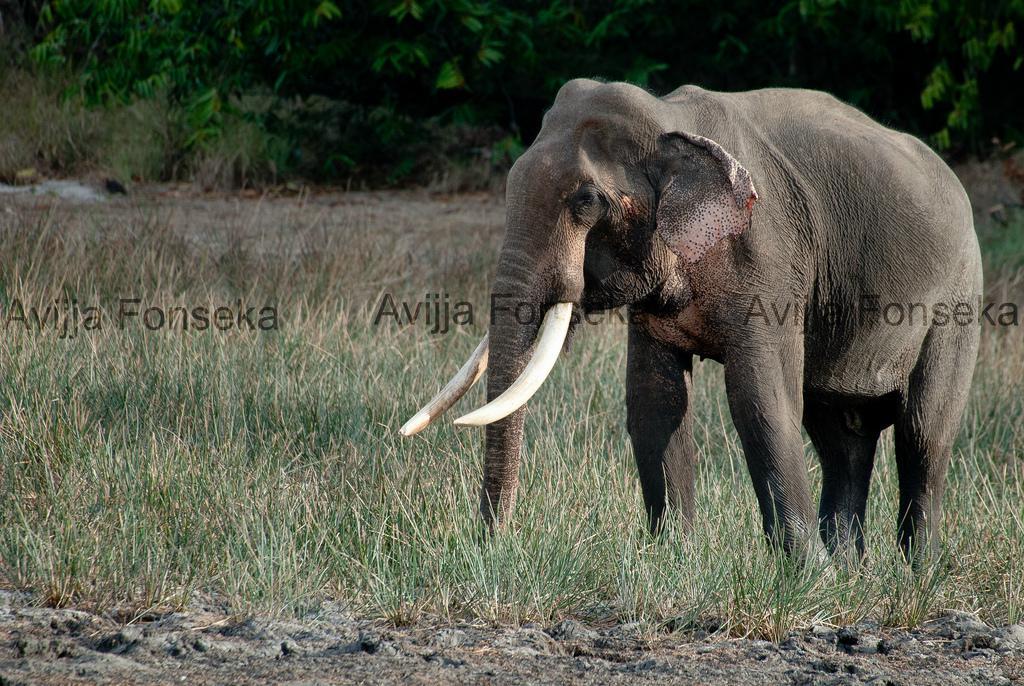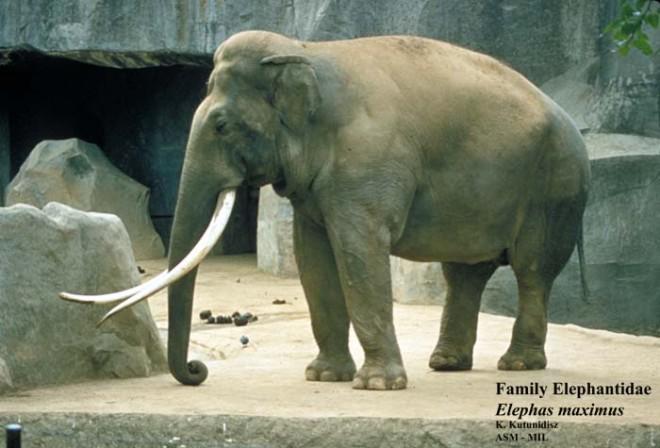The first image is the image on the left, the second image is the image on the right. Assess this claim about the two images: "Exactly one adult elephant with long, white ivory tusks is depicted in each image.". Correct or not? Answer yes or no. Yes. The first image is the image on the left, the second image is the image on the right. Considering the images on both sides, is "Left and right images depict one elephant, which has tusks." valid? Answer yes or no. Yes. 